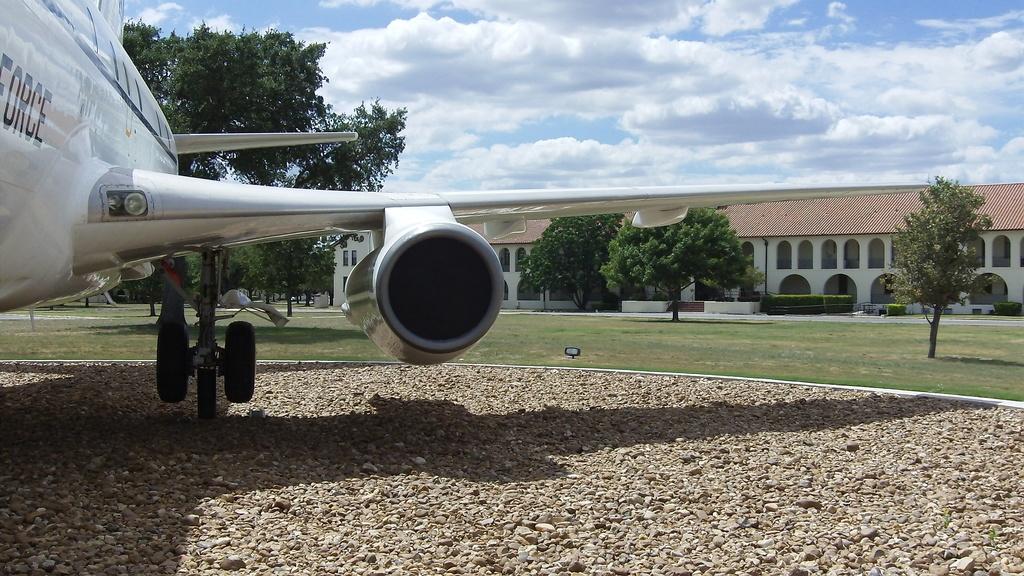What is the word you can see on the side of the plane?
Make the answer very short. Force. 